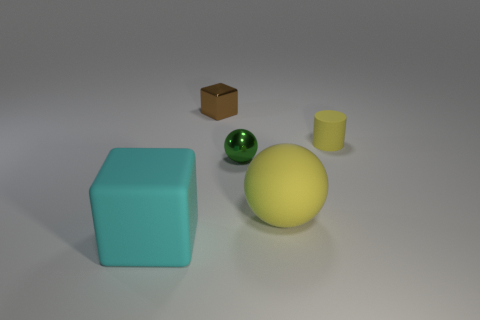Add 3 tiny green shiny spheres. How many objects exist? 8 Subtract all blocks. How many objects are left? 3 Subtract 1 yellow cylinders. How many objects are left? 4 Subtract all big red shiny blocks. Subtract all big cyan matte objects. How many objects are left? 4 Add 3 tiny brown blocks. How many tiny brown blocks are left? 4 Add 2 matte balls. How many matte balls exist? 3 